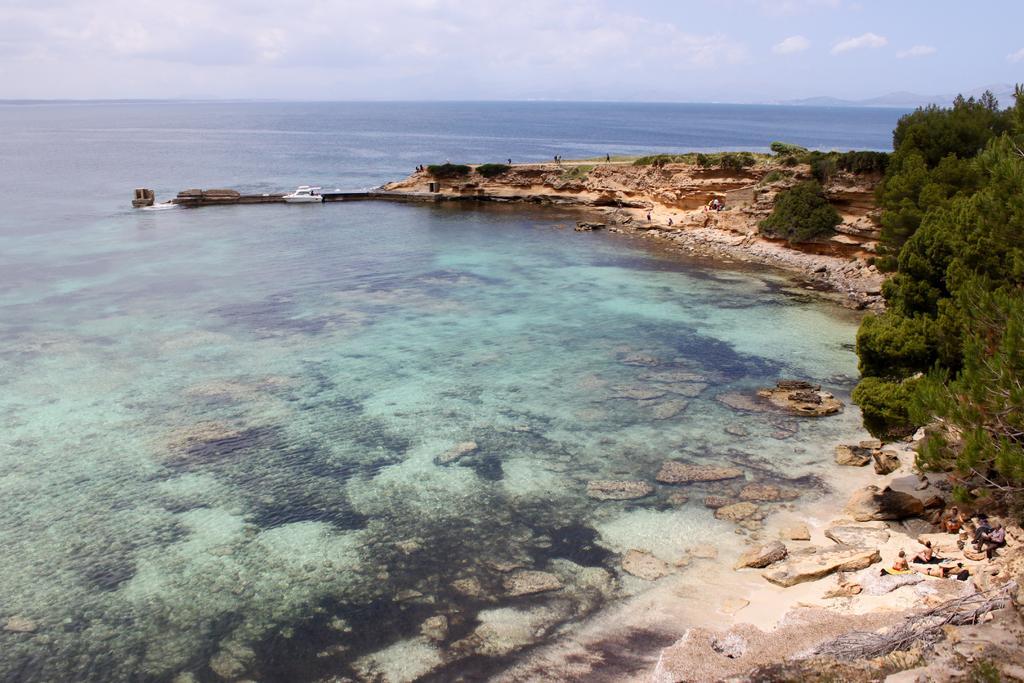Describe this image in one or two sentences. In this image, I think this is the sea with the water. I can see a boat. These are the trees. I can see the rocks. On the right side of the image, there are group of people sitting. 